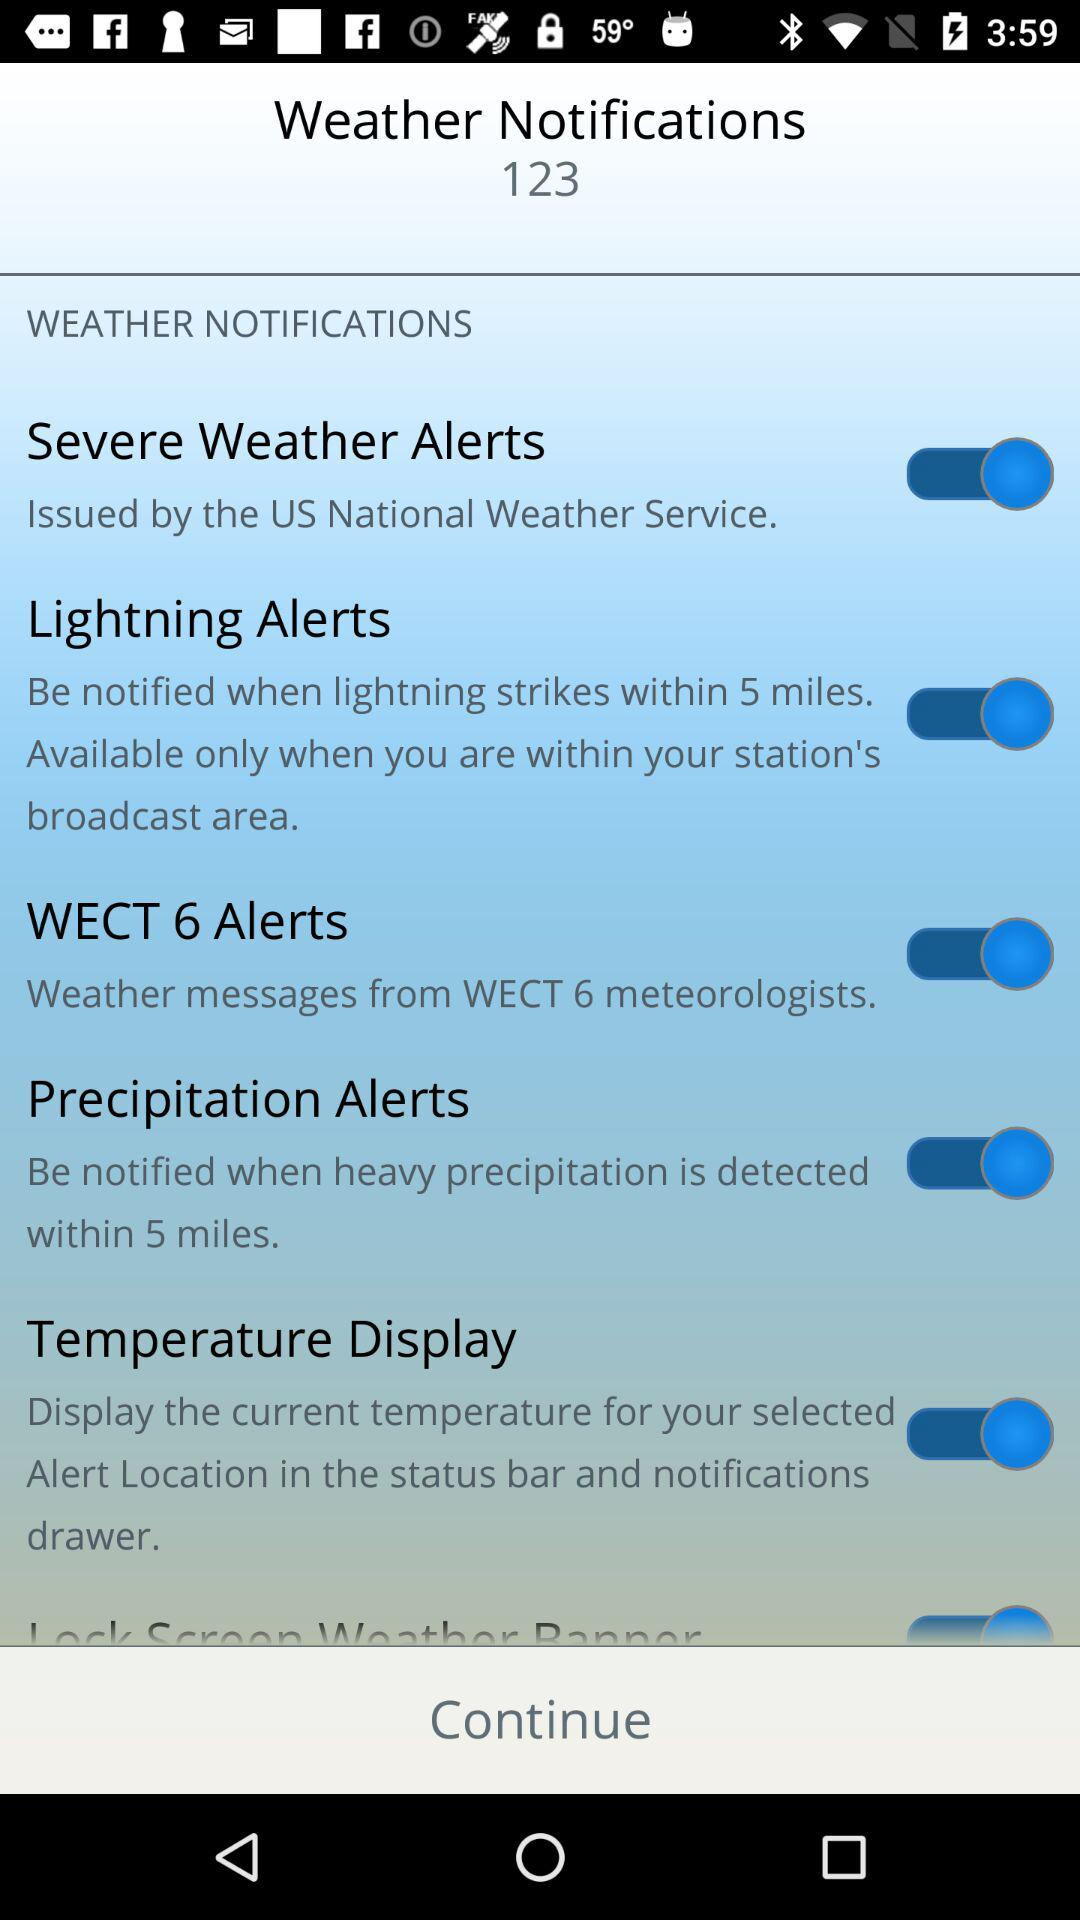What is the current status of the "Precipitation Alerts"? The current status is "on". 